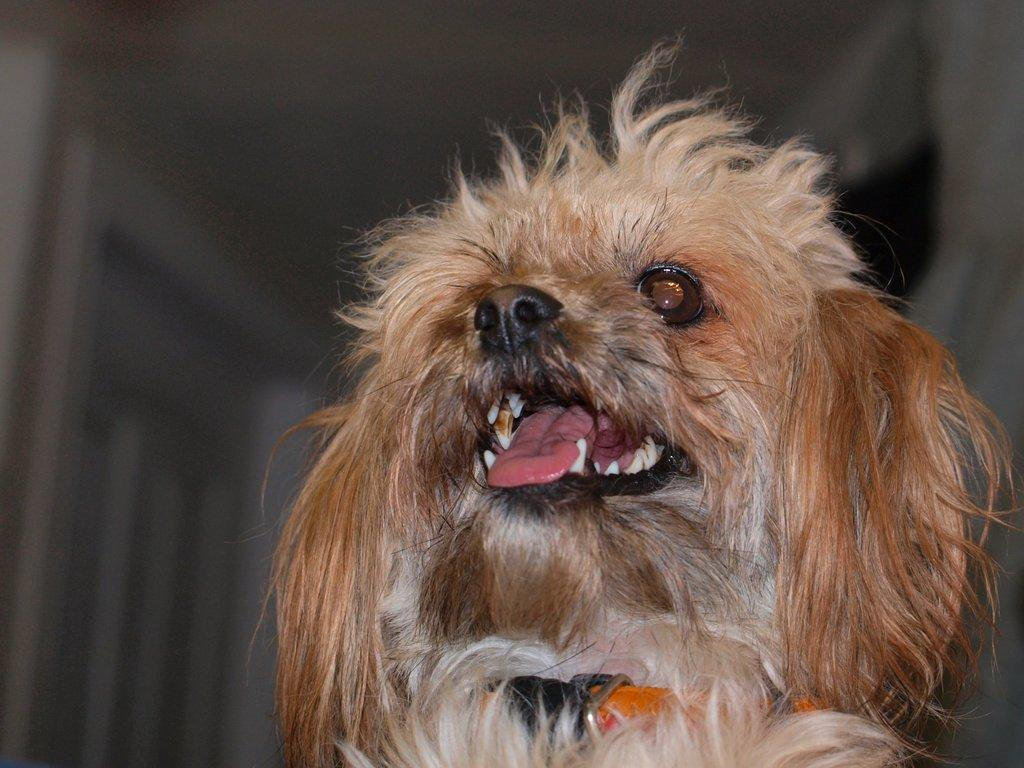What type of animal is in the image? There is a cream-colored dog in the image. Is there anything special about the dog's appearance? Yes, the dog is wearing an orange-colored belt around its neck. Can you describe the background of the image? The background of the image is blurry. How many trees can be seen in the image? There are no trees present in the image; it features a cream-colored dog wearing an orange-colored belt around its neck with a blurry background. 